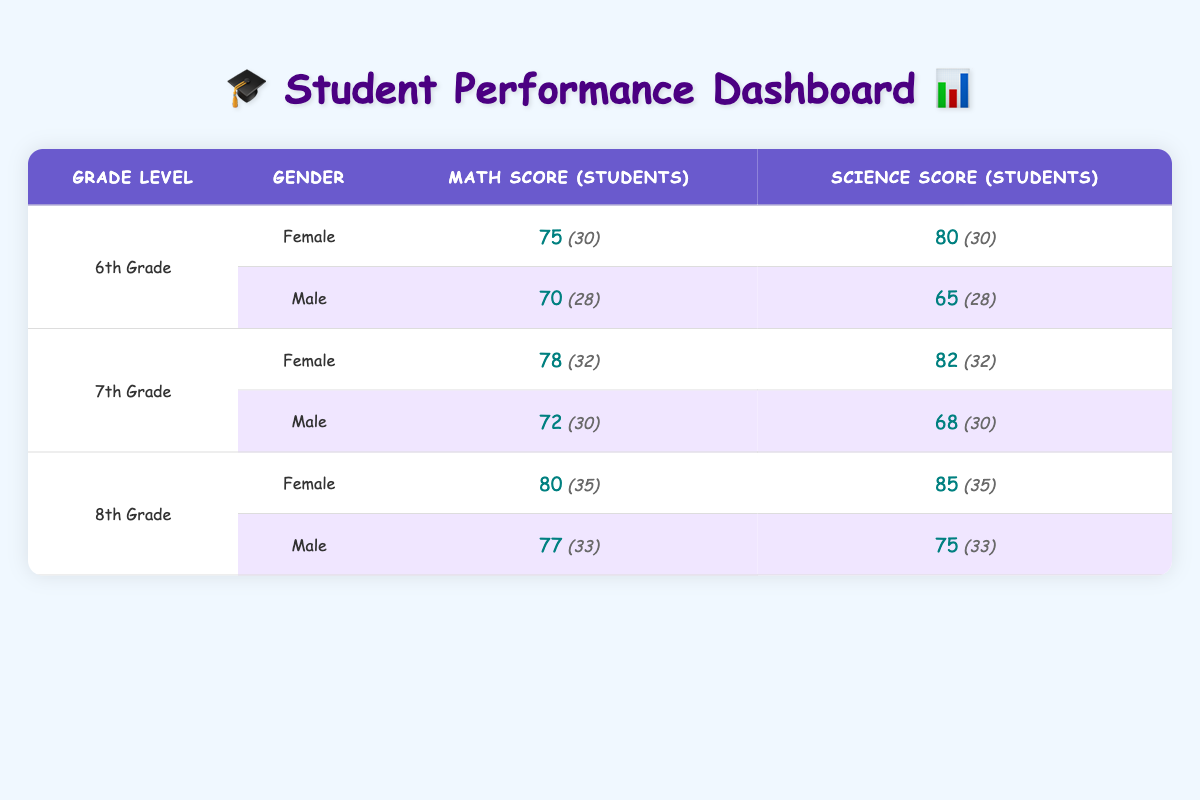What is the average score for 6th-grade female students in Math? The average score for 6th-grade female students in Math is directly provided in the table. The score is 75.
Answer: 75 What is the total number of male students in 7th grade? To find the total number of male students in 7th grade, look for all male entries under that grade. There are 30 male students in Math and 30 in Science. Adding these gives: 30 + 30 = 60.
Answer: 60 Did female students score higher in Science than male students in 8th grade? In 8th grade Science, female students scored 85 while male students scored 75. Since 85 is greater than 75, the answer is yes.
Answer: Yes What is the average score of 7th-grade students in Math? To find the average Math score for 7th grade, sum the scores of both genders: 78 (female) + 72 (male) = 150. Then divide by 2 (the number of groups): 150/2 = 75.
Answer: 75 Which grade level had the highest average score in Science overall? Examine the average Science scores for each grade: 6th grade scores 77.5 (80 for females and 65 for males), 7th grade scores 75 (82 for females and 68 for males), and 8th grade scores 80 (85 for females and 75 for males). The highest average is thus 80 in 8th grade.
Answer: 8th Grade What is the difference in average scores between male and female students in 6th grade Math? In 6th grade, female students scored 75 in Math while male students scored 70. The difference is: 75 - 70 = 5.
Answer: 5 How many students performed better in Math than in Science among male students in 7th grade? Check the scores for male students in Math (72) and Science (68). Since 72 is greater than 68, all 30 male students scored higher in Math.
Answer: 30 Is the average score of female students in Math higher than that of male students in the same grade level? For 6th grade: females scored 75 while males scored 70. For 7th grade: females scored 78 and males scored 72. For 8th grade: females scored 80 and males scored 77. In all cases, females scored higher, so the answer is yes.
Answer: Yes What is the total average score for all 8th grade students in Math? In 8th grade, female students scored 80 and male students scored 77. To find the total average, add these scores: 80 + 77 = 157, then divide by 2: 157 / 2 = 78.5.
Answer: 78.5 